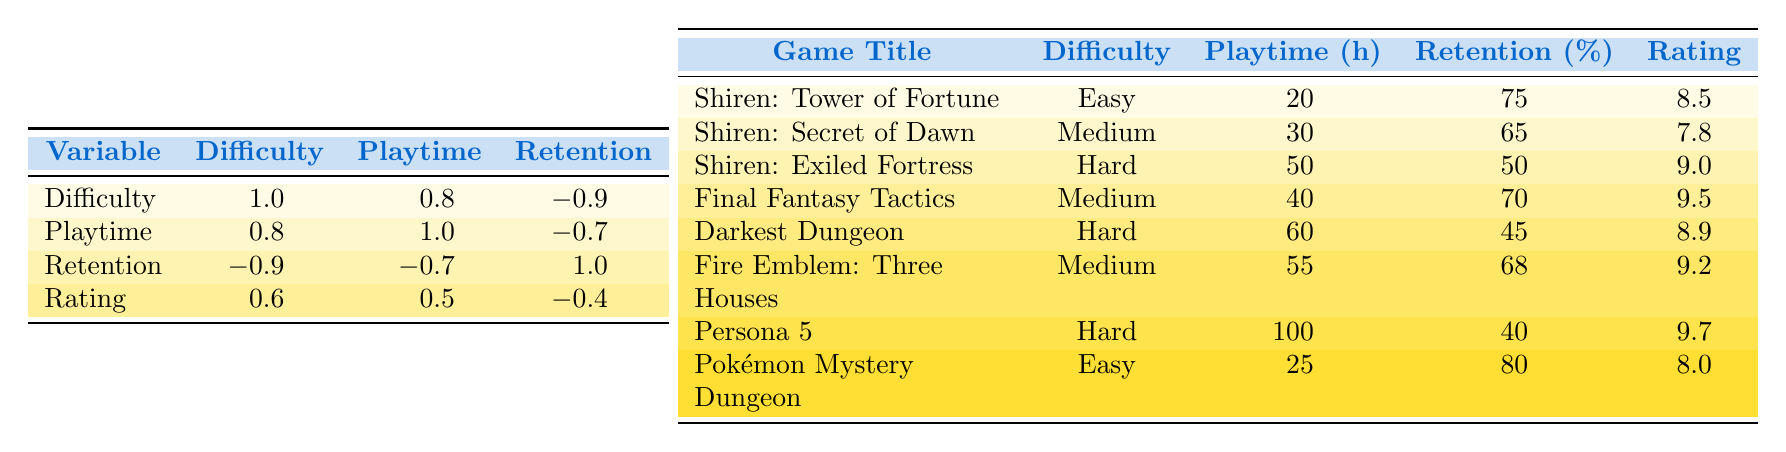What is the average playtime for the "Shiren the Wanderer" games? The playtime values for the "Shiren the Wanderer" games are 20, 30, and 50 hours. Therefore, we sum these values: 20 + 30 + 50 = 100. Since there are 3 games, we find the average by dividing the total by 3: 100/3 = 33.33.
Answer: 33.33 Which game has the highest average player rating? Looking through the ratings provided in the table, "Persona 5" has the highest rating at 9.7.
Answer: Persona 5 Is the retention rate higher for easy difficulty compared to hard difficulty? From the table, the easy difficulty games have retention rates of 75% and 80%, while the hard difficulty games have retention rates of 50%, 45%, and 40%. Since both easy games have higher retention rates compared to the hard games, the answer is yes.
Answer: Yes What is the difference in average playtime between hard and easy difficulty games? The average playtime for easy difficulty games is 22.5 hours (average of 20 and 25 hours) and for hard difficulty games, it is 70 hours (average of 50, 60, and 100 hours). The difference is calculated as 70 - 22.5 = 47.5 hours.
Answer: 47.5 How many games have a player retention rate of 65% or lower? Looking at the table, there are 3 games with retention rates of 65% or lower: "Shiren the Wanderer: The Exiled Fortress" (50%), "Darkest Dungeon" (45%), and "Persona 5" (40%). Therefore, the count is 3.
Answer: 3 